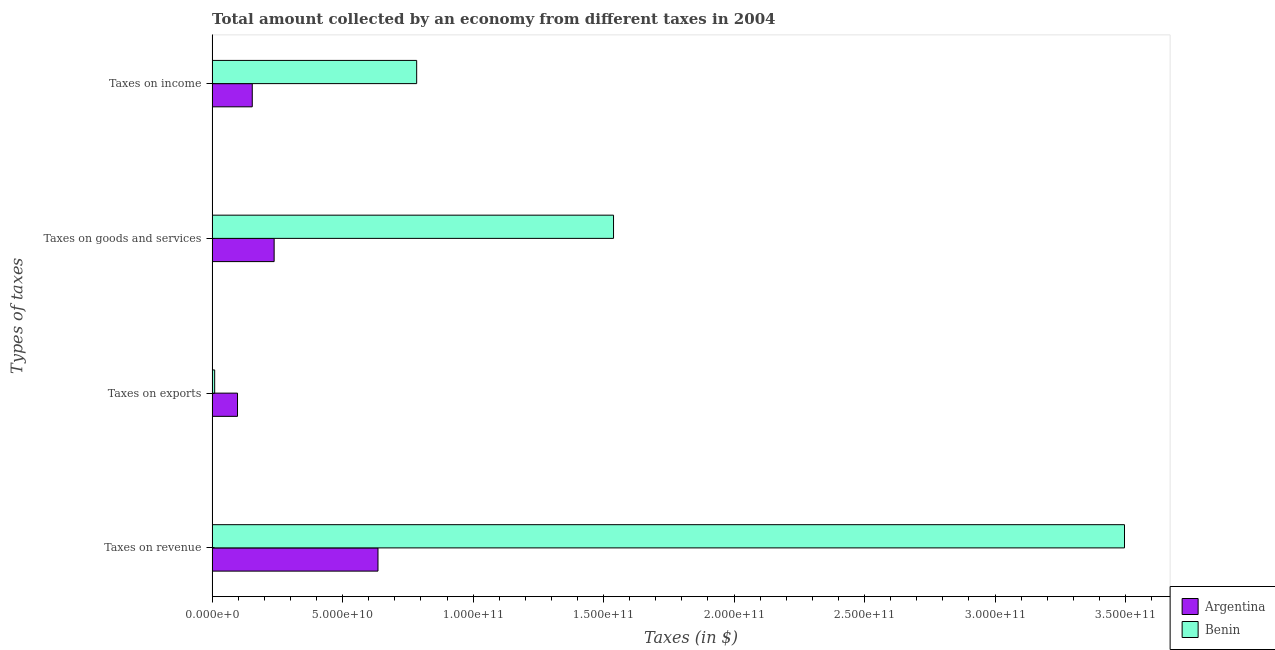How many groups of bars are there?
Offer a very short reply. 4. Are the number of bars per tick equal to the number of legend labels?
Offer a very short reply. Yes. Are the number of bars on each tick of the Y-axis equal?
Make the answer very short. Yes. How many bars are there on the 1st tick from the top?
Make the answer very short. 2. What is the label of the 1st group of bars from the top?
Your response must be concise. Taxes on income. What is the amount collected as tax on goods in Benin?
Your answer should be compact. 1.54e+11. Across all countries, what is the maximum amount collected as tax on goods?
Your answer should be very brief. 1.54e+11. Across all countries, what is the minimum amount collected as tax on goods?
Make the answer very short. 2.38e+1. In which country was the amount collected as tax on income maximum?
Give a very brief answer. Benin. In which country was the amount collected as tax on income minimum?
Your answer should be compact. Argentina. What is the total amount collected as tax on goods in the graph?
Offer a terse response. 1.78e+11. What is the difference between the amount collected as tax on goods in Argentina and that in Benin?
Your response must be concise. -1.30e+11. What is the difference between the amount collected as tax on revenue in Benin and the amount collected as tax on goods in Argentina?
Offer a terse response. 3.26e+11. What is the average amount collected as tax on exports per country?
Give a very brief answer. 5.35e+09. What is the difference between the amount collected as tax on exports and amount collected as tax on goods in Argentina?
Offer a very short reply. -1.40e+1. In how many countries, is the amount collected as tax on revenue greater than 230000000000 $?
Your response must be concise. 1. What is the ratio of the amount collected as tax on exports in Argentina to that in Benin?
Provide a short and direct response. 9.97. Is the amount collected as tax on exports in Argentina less than that in Benin?
Your answer should be very brief. No. What is the difference between the highest and the second highest amount collected as tax on goods?
Ensure brevity in your answer.  1.30e+11. What is the difference between the highest and the lowest amount collected as tax on revenue?
Give a very brief answer. 2.86e+11. What does the 2nd bar from the top in Taxes on revenue represents?
Provide a short and direct response. Argentina. What does the 1st bar from the bottom in Taxes on exports represents?
Provide a succinct answer. Argentina. How many bars are there?
Your answer should be compact. 8. How many countries are there in the graph?
Your answer should be very brief. 2. Does the graph contain any zero values?
Your response must be concise. No. How are the legend labels stacked?
Your response must be concise. Vertical. What is the title of the graph?
Provide a succinct answer. Total amount collected by an economy from different taxes in 2004. What is the label or title of the X-axis?
Provide a short and direct response. Taxes (in $). What is the label or title of the Y-axis?
Your response must be concise. Types of taxes. What is the Taxes (in $) in Argentina in Taxes on revenue?
Ensure brevity in your answer.  6.36e+1. What is the Taxes (in $) of Benin in Taxes on revenue?
Provide a succinct answer. 3.50e+11. What is the Taxes (in $) in Argentina in Taxes on exports?
Offer a terse response. 9.73e+09. What is the Taxes (in $) of Benin in Taxes on exports?
Provide a short and direct response. 9.76e+08. What is the Taxes (in $) in Argentina in Taxes on goods and services?
Provide a short and direct response. 2.38e+1. What is the Taxes (in $) of Benin in Taxes on goods and services?
Give a very brief answer. 1.54e+11. What is the Taxes (in $) in Argentina in Taxes on income?
Make the answer very short. 1.54e+1. What is the Taxes (in $) in Benin in Taxes on income?
Make the answer very short. 7.84e+1. Across all Types of taxes, what is the maximum Taxes (in $) of Argentina?
Provide a short and direct response. 6.36e+1. Across all Types of taxes, what is the maximum Taxes (in $) of Benin?
Your response must be concise. 3.50e+11. Across all Types of taxes, what is the minimum Taxes (in $) of Argentina?
Provide a succinct answer. 9.73e+09. Across all Types of taxes, what is the minimum Taxes (in $) in Benin?
Your response must be concise. 9.76e+08. What is the total Taxes (in $) of Argentina in the graph?
Offer a terse response. 1.12e+11. What is the total Taxes (in $) of Benin in the graph?
Your response must be concise. 5.83e+11. What is the difference between the Taxes (in $) in Argentina in Taxes on revenue and that in Taxes on exports?
Make the answer very short. 5.38e+1. What is the difference between the Taxes (in $) in Benin in Taxes on revenue and that in Taxes on exports?
Keep it short and to the point. 3.49e+11. What is the difference between the Taxes (in $) in Argentina in Taxes on revenue and that in Taxes on goods and services?
Offer a terse response. 3.98e+1. What is the difference between the Taxes (in $) in Benin in Taxes on revenue and that in Taxes on goods and services?
Your answer should be compact. 1.96e+11. What is the difference between the Taxes (in $) in Argentina in Taxes on revenue and that in Taxes on income?
Your answer should be compact. 4.82e+1. What is the difference between the Taxes (in $) of Benin in Taxes on revenue and that in Taxes on income?
Keep it short and to the point. 2.71e+11. What is the difference between the Taxes (in $) of Argentina in Taxes on exports and that in Taxes on goods and services?
Your answer should be compact. -1.40e+1. What is the difference between the Taxes (in $) in Benin in Taxes on exports and that in Taxes on goods and services?
Give a very brief answer. -1.53e+11. What is the difference between the Taxes (in $) in Argentina in Taxes on exports and that in Taxes on income?
Provide a succinct answer. -5.65e+09. What is the difference between the Taxes (in $) in Benin in Taxes on exports and that in Taxes on income?
Your answer should be compact. -7.74e+1. What is the difference between the Taxes (in $) in Argentina in Taxes on goods and services and that in Taxes on income?
Make the answer very short. 8.38e+09. What is the difference between the Taxes (in $) of Benin in Taxes on goods and services and that in Taxes on income?
Offer a very short reply. 7.54e+1. What is the difference between the Taxes (in $) of Argentina in Taxes on revenue and the Taxes (in $) of Benin in Taxes on exports?
Offer a very short reply. 6.26e+1. What is the difference between the Taxes (in $) in Argentina in Taxes on revenue and the Taxes (in $) in Benin in Taxes on goods and services?
Ensure brevity in your answer.  -9.03e+1. What is the difference between the Taxes (in $) in Argentina in Taxes on revenue and the Taxes (in $) in Benin in Taxes on income?
Keep it short and to the point. -1.48e+1. What is the difference between the Taxes (in $) in Argentina in Taxes on exports and the Taxes (in $) in Benin in Taxes on goods and services?
Offer a very short reply. -1.44e+11. What is the difference between the Taxes (in $) in Argentina in Taxes on exports and the Taxes (in $) in Benin in Taxes on income?
Keep it short and to the point. -6.86e+1. What is the difference between the Taxes (in $) in Argentina in Taxes on goods and services and the Taxes (in $) in Benin in Taxes on income?
Keep it short and to the point. -5.46e+1. What is the average Taxes (in $) in Argentina per Types of taxes?
Provide a succinct answer. 2.81e+1. What is the average Taxes (in $) in Benin per Types of taxes?
Give a very brief answer. 1.46e+11. What is the difference between the Taxes (in $) in Argentina and Taxes (in $) in Benin in Taxes on revenue?
Keep it short and to the point. -2.86e+11. What is the difference between the Taxes (in $) of Argentina and Taxes (in $) of Benin in Taxes on exports?
Give a very brief answer. 8.75e+09. What is the difference between the Taxes (in $) of Argentina and Taxes (in $) of Benin in Taxes on goods and services?
Your answer should be compact. -1.30e+11. What is the difference between the Taxes (in $) in Argentina and Taxes (in $) in Benin in Taxes on income?
Your response must be concise. -6.30e+1. What is the ratio of the Taxes (in $) of Argentina in Taxes on revenue to that in Taxes on exports?
Provide a succinct answer. 6.53. What is the ratio of the Taxes (in $) in Benin in Taxes on revenue to that in Taxes on exports?
Your answer should be compact. 358.36. What is the ratio of the Taxes (in $) of Argentina in Taxes on revenue to that in Taxes on goods and services?
Make the answer very short. 2.67. What is the ratio of the Taxes (in $) of Benin in Taxes on revenue to that in Taxes on goods and services?
Ensure brevity in your answer.  2.27. What is the ratio of the Taxes (in $) in Argentina in Taxes on revenue to that in Taxes on income?
Give a very brief answer. 4.13. What is the ratio of the Taxes (in $) of Benin in Taxes on revenue to that in Taxes on income?
Provide a succinct answer. 4.46. What is the ratio of the Taxes (in $) in Argentina in Taxes on exports to that in Taxes on goods and services?
Make the answer very short. 0.41. What is the ratio of the Taxes (in $) in Benin in Taxes on exports to that in Taxes on goods and services?
Your answer should be very brief. 0.01. What is the ratio of the Taxes (in $) of Argentina in Taxes on exports to that in Taxes on income?
Offer a very short reply. 0.63. What is the ratio of the Taxes (in $) of Benin in Taxes on exports to that in Taxes on income?
Provide a short and direct response. 0.01. What is the ratio of the Taxes (in $) of Argentina in Taxes on goods and services to that in Taxes on income?
Offer a terse response. 1.55. What is the ratio of the Taxes (in $) of Benin in Taxes on goods and services to that in Taxes on income?
Offer a terse response. 1.96. What is the difference between the highest and the second highest Taxes (in $) of Argentina?
Offer a terse response. 3.98e+1. What is the difference between the highest and the second highest Taxes (in $) of Benin?
Offer a very short reply. 1.96e+11. What is the difference between the highest and the lowest Taxes (in $) in Argentina?
Offer a very short reply. 5.38e+1. What is the difference between the highest and the lowest Taxes (in $) of Benin?
Offer a very short reply. 3.49e+11. 